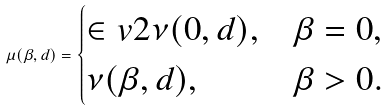<formula> <loc_0><loc_0><loc_500><loc_500>\mu ( \beta , d ) = \begin{cases} \in v { 2 } \nu ( 0 , d ) , & \beta = 0 , \\ \nu ( \beta , d ) , & \beta > 0 . \end{cases}</formula> 